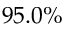Convert formula to latex. <formula><loc_0><loc_0><loc_500><loc_500>9 5 . 0 \%</formula> 